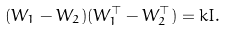Convert formula to latex. <formula><loc_0><loc_0><loc_500><loc_500>( W _ { 1 } - W _ { 2 } ) ( W _ { 1 } ^ { \top } - W _ { 2 } ^ { \top } ) & = k I .</formula> 